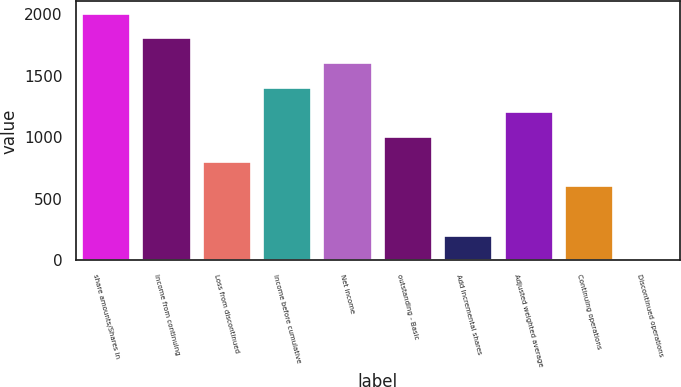Convert chart to OTSL. <chart><loc_0><loc_0><loc_500><loc_500><bar_chart><fcel>share amounts/Shares in<fcel>Income from continuing<fcel>Loss from discontinued<fcel>Income before cumulative<fcel>Net income<fcel>outstanding - Basic<fcel>Add Incremental shares<fcel>Adjusted weighted average<fcel>Continuing operations<fcel>Discontinued operations<nl><fcel>2003<fcel>1802.75<fcel>801.5<fcel>1402.25<fcel>1602.5<fcel>1001.75<fcel>200.75<fcel>1202<fcel>601.25<fcel>0.5<nl></chart> 